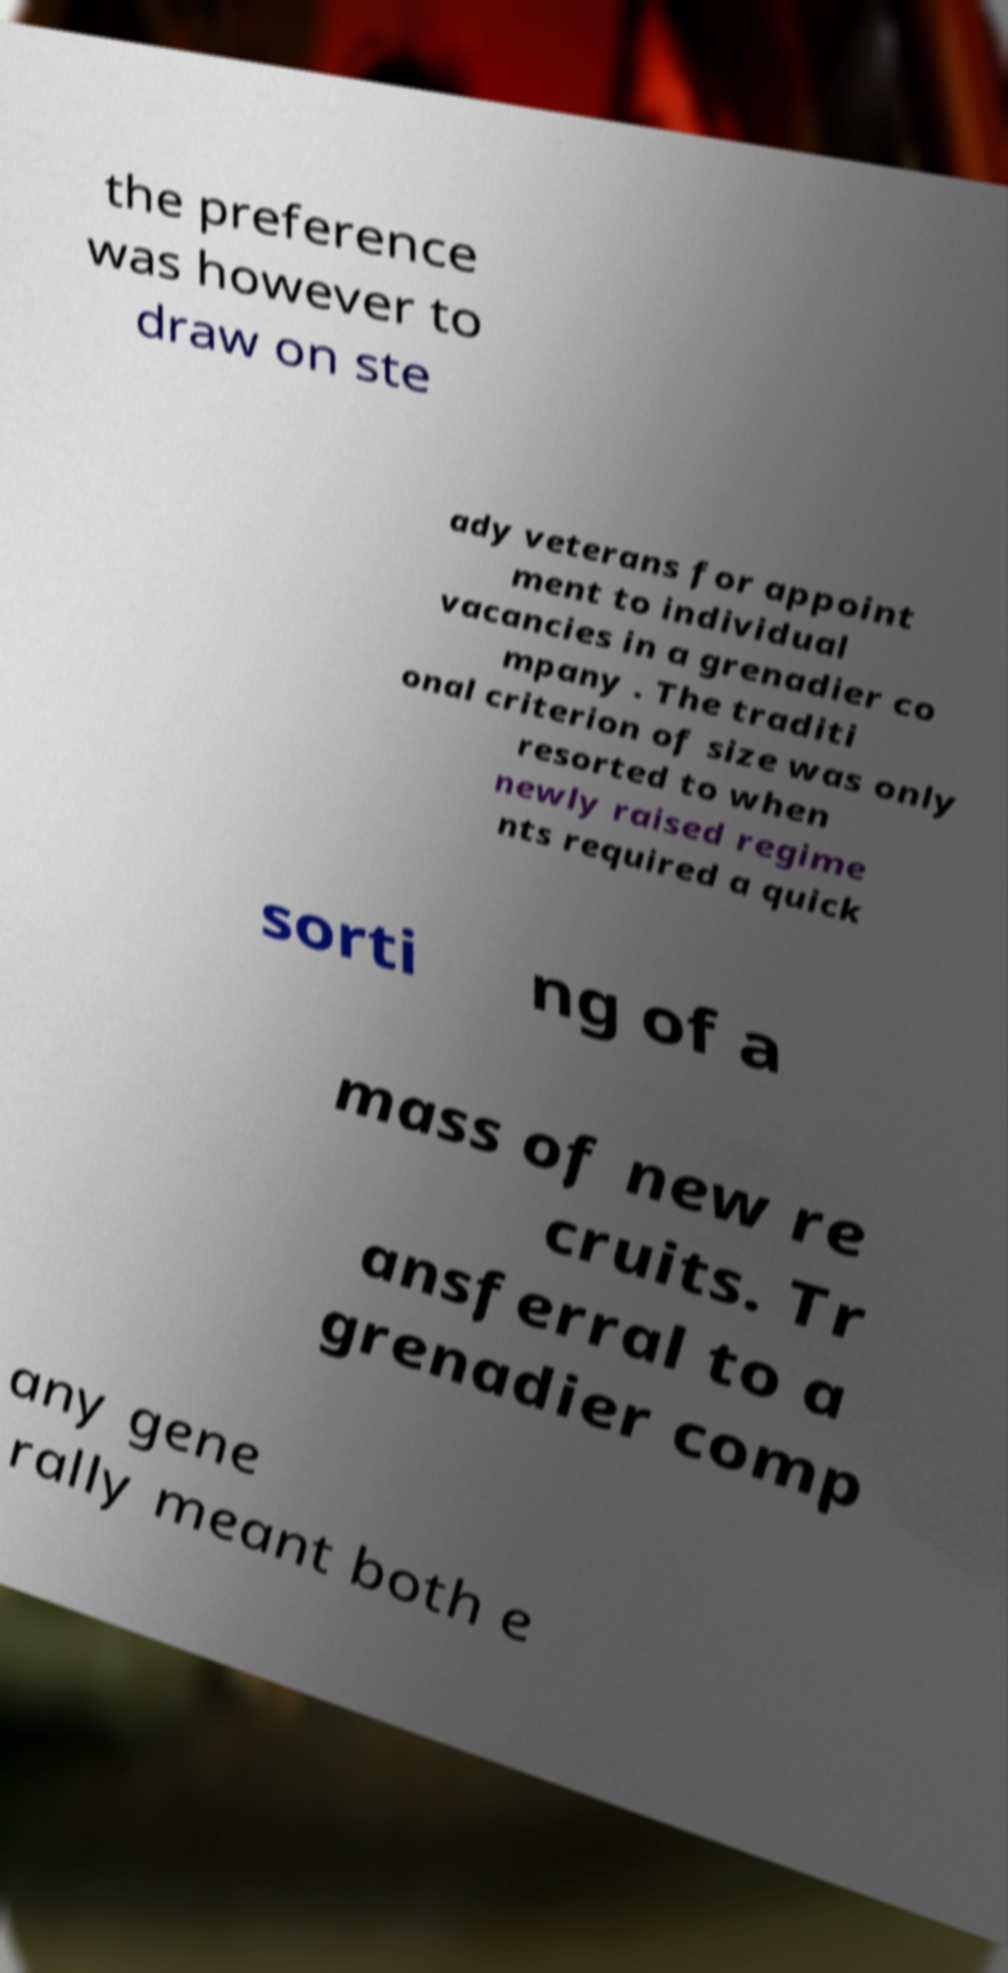I need the written content from this picture converted into text. Can you do that? the preference was however to draw on ste ady veterans for appoint ment to individual vacancies in a grenadier co mpany . The traditi onal criterion of size was only resorted to when newly raised regime nts required a quick sorti ng of a mass of new re cruits. Tr ansferral to a grenadier comp any gene rally meant both e 